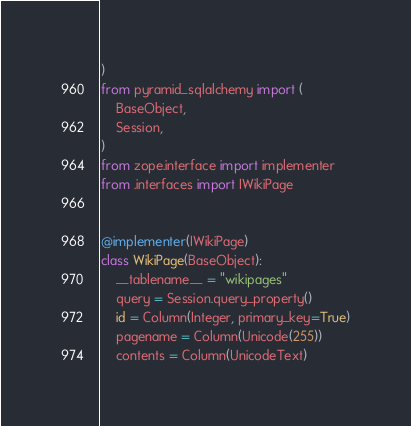<code> <loc_0><loc_0><loc_500><loc_500><_Python_>)
from pyramid_sqlalchemy import (
    BaseObject,
    Session,
)
from zope.interface import implementer
from .interfaces import IWikiPage


@implementer(IWikiPage)
class WikiPage(BaseObject):
    __tablename__ = "wikipages"
    query = Session.query_property()
    id = Column(Integer, primary_key=True)
    pagename = Column(Unicode(255))
    contents = Column(UnicodeText)
</code> 